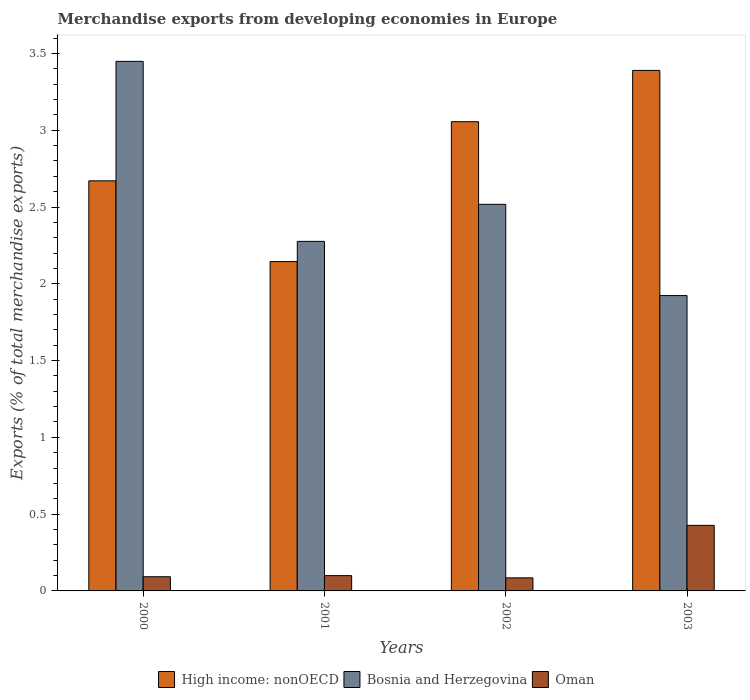How many groups of bars are there?
Provide a succinct answer. 4. How many bars are there on the 2nd tick from the left?
Provide a short and direct response. 3. How many bars are there on the 4th tick from the right?
Offer a terse response. 3. In how many cases, is the number of bars for a given year not equal to the number of legend labels?
Your response must be concise. 0. What is the percentage of total merchandise exports in Bosnia and Herzegovina in 2000?
Provide a succinct answer. 3.45. Across all years, what is the maximum percentage of total merchandise exports in High income: nonOECD?
Make the answer very short. 3.39. Across all years, what is the minimum percentage of total merchandise exports in High income: nonOECD?
Provide a short and direct response. 2.14. In which year was the percentage of total merchandise exports in High income: nonOECD minimum?
Give a very brief answer. 2001. What is the total percentage of total merchandise exports in Oman in the graph?
Keep it short and to the point. 0.7. What is the difference between the percentage of total merchandise exports in Bosnia and Herzegovina in 2002 and that in 2003?
Give a very brief answer. 0.59. What is the difference between the percentage of total merchandise exports in High income: nonOECD in 2000 and the percentage of total merchandise exports in Oman in 2001?
Make the answer very short. 2.57. What is the average percentage of total merchandise exports in Oman per year?
Ensure brevity in your answer.  0.18. In the year 2003, what is the difference between the percentage of total merchandise exports in Oman and percentage of total merchandise exports in Bosnia and Herzegovina?
Your answer should be compact. -1.5. In how many years, is the percentage of total merchandise exports in High income: nonOECD greater than 1.5 %?
Your response must be concise. 4. What is the ratio of the percentage of total merchandise exports in High income: nonOECD in 2001 to that in 2002?
Keep it short and to the point. 0.7. What is the difference between the highest and the second highest percentage of total merchandise exports in Oman?
Offer a very short reply. 0.33. What is the difference between the highest and the lowest percentage of total merchandise exports in High income: nonOECD?
Make the answer very short. 1.24. In how many years, is the percentage of total merchandise exports in High income: nonOECD greater than the average percentage of total merchandise exports in High income: nonOECD taken over all years?
Your answer should be compact. 2. Is the sum of the percentage of total merchandise exports in High income: nonOECD in 2000 and 2002 greater than the maximum percentage of total merchandise exports in Bosnia and Herzegovina across all years?
Offer a very short reply. Yes. What does the 1st bar from the left in 2001 represents?
Your response must be concise. High income: nonOECD. What does the 3rd bar from the right in 2002 represents?
Give a very brief answer. High income: nonOECD. Are all the bars in the graph horizontal?
Offer a very short reply. No. How many years are there in the graph?
Provide a short and direct response. 4. What is the difference between two consecutive major ticks on the Y-axis?
Offer a very short reply. 0.5. Are the values on the major ticks of Y-axis written in scientific E-notation?
Your answer should be very brief. No. How many legend labels are there?
Provide a succinct answer. 3. How are the legend labels stacked?
Your response must be concise. Horizontal. What is the title of the graph?
Provide a succinct answer. Merchandise exports from developing economies in Europe. Does "St. Lucia" appear as one of the legend labels in the graph?
Provide a succinct answer. No. What is the label or title of the X-axis?
Your answer should be very brief. Years. What is the label or title of the Y-axis?
Provide a short and direct response. Exports (% of total merchandise exports). What is the Exports (% of total merchandise exports) in High income: nonOECD in 2000?
Ensure brevity in your answer.  2.67. What is the Exports (% of total merchandise exports) in Bosnia and Herzegovina in 2000?
Ensure brevity in your answer.  3.45. What is the Exports (% of total merchandise exports) in Oman in 2000?
Give a very brief answer. 0.09. What is the Exports (% of total merchandise exports) in High income: nonOECD in 2001?
Your response must be concise. 2.14. What is the Exports (% of total merchandise exports) in Bosnia and Herzegovina in 2001?
Ensure brevity in your answer.  2.28. What is the Exports (% of total merchandise exports) in Oman in 2001?
Offer a terse response. 0.1. What is the Exports (% of total merchandise exports) of High income: nonOECD in 2002?
Your answer should be very brief. 3.06. What is the Exports (% of total merchandise exports) in Bosnia and Herzegovina in 2002?
Your response must be concise. 2.52. What is the Exports (% of total merchandise exports) in Oman in 2002?
Your answer should be compact. 0.09. What is the Exports (% of total merchandise exports) of High income: nonOECD in 2003?
Your response must be concise. 3.39. What is the Exports (% of total merchandise exports) of Bosnia and Herzegovina in 2003?
Your response must be concise. 1.92. What is the Exports (% of total merchandise exports) of Oman in 2003?
Provide a short and direct response. 0.43. Across all years, what is the maximum Exports (% of total merchandise exports) in High income: nonOECD?
Keep it short and to the point. 3.39. Across all years, what is the maximum Exports (% of total merchandise exports) in Bosnia and Herzegovina?
Your response must be concise. 3.45. Across all years, what is the maximum Exports (% of total merchandise exports) in Oman?
Ensure brevity in your answer.  0.43. Across all years, what is the minimum Exports (% of total merchandise exports) in High income: nonOECD?
Your response must be concise. 2.14. Across all years, what is the minimum Exports (% of total merchandise exports) of Bosnia and Herzegovina?
Provide a short and direct response. 1.92. Across all years, what is the minimum Exports (% of total merchandise exports) of Oman?
Provide a short and direct response. 0.09. What is the total Exports (% of total merchandise exports) of High income: nonOECD in the graph?
Your response must be concise. 11.26. What is the total Exports (% of total merchandise exports) of Bosnia and Herzegovina in the graph?
Your answer should be very brief. 10.17. What is the total Exports (% of total merchandise exports) of Oman in the graph?
Keep it short and to the point. 0.7. What is the difference between the Exports (% of total merchandise exports) in High income: nonOECD in 2000 and that in 2001?
Your answer should be very brief. 0.53. What is the difference between the Exports (% of total merchandise exports) in Bosnia and Herzegovina in 2000 and that in 2001?
Your answer should be very brief. 1.17. What is the difference between the Exports (% of total merchandise exports) of Oman in 2000 and that in 2001?
Offer a terse response. -0.01. What is the difference between the Exports (% of total merchandise exports) in High income: nonOECD in 2000 and that in 2002?
Give a very brief answer. -0.39. What is the difference between the Exports (% of total merchandise exports) of Bosnia and Herzegovina in 2000 and that in 2002?
Your answer should be very brief. 0.93. What is the difference between the Exports (% of total merchandise exports) of Oman in 2000 and that in 2002?
Offer a terse response. 0.01. What is the difference between the Exports (% of total merchandise exports) of High income: nonOECD in 2000 and that in 2003?
Provide a short and direct response. -0.72. What is the difference between the Exports (% of total merchandise exports) in Bosnia and Herzegovina in 2000 and that in 2003?
Keep it short and to the point. 1.53. What is the difference between the Exports (% of total merchandise exports) of Oman in 2000 and that in 2003?
Your answer should be very brief. -0.33. What is the difference between the Exports (% of total merchandise exports) of High income: nonOECD in 2001 and that in 2002?
Your response must be concise. -0.91. What is the difference between the Exports (% of total merchandise exports) in Bosnia and Herzegovina in 2001 and that in 2002?
Keep it short and to the point. -0.24. What is the difference between the Exports (% of total merchandise exports) in Oman in 2001 and that in 2002?
Your response must be concise. 0.01. What is the difference between the Exports (% of total merchandise exports) in High income: nonOECD in 2001 and that in 2003?
Provide a short and direct response. -1.24. What is the difference between the Exports (% of total merchandise exports) of Bosnia and Herzegovina in 2001 and that in 2003?
Ensure brevity in your answer.  0.35. What is the difference between the Exports (% of total merchandise exports) of Oman in 2001 and that in 2003?
Offer a terse response. -0.33. What is the difference between the Exports (% of total merchandise exports) of High income: nonOECD in 2002 and that in 2003?
Offer a terse response. -0.33. What is the difference between the Exports (% of total merchandise exports) in Bosnia and Herzegovina in 2002 and that in 2003?
Offer a very short reply. 0.59. What is the difference between the Exports (% of total merchandise exports) of Oman in 2002 and that in 2003?
Your answer should be compact. -0.34. What is the difference between the Exports (% of total merchandise exports) of High income: nonOECD in 2000 and the Exports (% of total merchandise exports) of Bosnia and Herzegovina in 2001?
Your answer should be very brief. 0.39. What is the difference between the Exports (% of total merchandise exports) of High income: nonOECD in 2000 and the Exports (% of total merchandise exports) of Oman in 2001?
Offer a terse response. 2.57. What is the difference between the Exports (% of total merchandise exports) in Bosnia and Herzegovina in 2000 and the Exports (% of total merchandise exports) in Oman in 2001?
Make the answer very short. 3.35. What is the difference between the Exports (% of total merchandise exports) in High income: nonOECD in 2000 and the Exports (% of total merchandise exports) in Bosnia and Herzegovina in 2002?
Provide a succinct answer. 0.15. What is the difference between the Exports (% of total merchandise exports) in High income: nonOECD in 2000 and the Exports (% of total merchandise exports) in Oman in 2002?
Provide a short and direct response. 2.59. What is the difference between the Exports (% of total merchandise exports) in Bosnia and Herzegovina in 2000 and the Exports (% of total merchandise exports) in Oman in 2002?
Your answer should be compact. 3.36. What is the difference between the Exports (% of total merchandise exports) of High income: nonOECD in 2000 and the Exports (% of total merchandise exports) of Bosnia and Herzegovina in 2003?
Keep it short and to the point. 0.75. What is the difference between the Exports (% of total merchandise exports) of High income: nonOECD in 2000 and the Exports (% of total merchandise exports) of Oman in 2003?
Offer a very short reply. 2.24. What is the difference between the Exports (% of total merchandise exports) in Bosnia and Herzegovina in 2000 and the Exports (% of total merchandise exports) in Oman in 2003?
Keep it short and to the point. 3.02. What is the difference between the Exports (% of total merchandise exports) of High income: nonOECD in 2001 and the Exports (% of total merchandise exports) of Bosnia and Herzegovina in 2002?
Your answer should be compact. -0.37. What is the difference between the Exports (% of total merchandise exports) of High income: nonOECD in 2001 and the Exports (% of total merchandise exports) of Oman in 2002?
Give a very brief answer. 2.06. What is the difference between the Exports (% of total merchandise exports) of Bosnia and Herzegovina in 2001 and the Exports (% of total merchandise exports) of Oman in 2002?
Ensure brevity in your answer.  2.19. What is the difference between the Exports (% of total merchandise exports) in High income: nonOECD in 2001 and the Exports (% of total merchandise exports) in Bosnia and Herzegovina in 2003?
Ensure brevity in your answer.  0.22. What is the difference between the Exports (% of total merchandise exports) of High income: nonOECD in 2001 and the Exports (% of total merchandise exports) of Oman in 2003?
Offer a very short reply. 1.72. What is the difference between the Exports (% of total merchandise exports) in Bosnia and Herzegovina in 2001 and the Exports (% of total merchandise exports) in Oman in 2003?
Ensure brevity in your answer.  1.85. What is the difference between the Exports (% of total merchandise exports) in High income: nonOECD in 2002 and the Exports (% of total merchandise exports) in Bosnia and Herzegovina in 2003?
Keep it short and to the point. 1.13. What is the difference between the Exports (% of total merchandise exports) of High income: nonOECD in 2002 and the Exports (% of total merchandise exports) of Oman in 2003?
Keep it short and to the point. 2.63. What is the difference between the Exports (% of total merchandise exports) in Bosnia and Herzegovina in 2002 and the Exports (% of total merchandise exports) in Oman in 2003?
Ensure brevity in your answer.  2.09. What is the average Exports (% of total merchandise exports) in High income: nonOECD per year?
Provide a short and direct response. 2.81. What is the average Exports (% of total merchandise exports) in Bosnia and Herzegovina per year?
Provide a succinct answer. 2.54. What is the average Exports (% of total merchandise exports) in Oman per year?
Your response must be concise. 0.18. In the year 2000, what is the difference between the Exports (% of total merchandise exports) of High income: nonOECD and Exports (% of total merchandise exports) of Bosnia and Herzegovina?
Provide a short and direct response. -0.78. In the year 2000, what is the difference between the Exports (% of total merchandise exports) in High income: nonOECD and Exports (% of total merchandise exports) in Oman?
Keep it short and to the point. 2.58. In the year 2000, what is the difference between the Exports (% of total merchandise exports) in Bosnia and Herzegovina and Exports (% of total merchandise exports) in Oman?
Make the answer very short. 3.36. In the year 2001, what is the difference between the Exports (% of total merchandise exports) of High income: nonOECD and Exports (% of total merchandise exports) of Bosnia and Herzegovina?
Offer a very short reply. -0.13. In the year 2001, what is the difference between the Exports (% of total merchandise exports) of High income: nonOECD and Exports (% of total merchandise exports) of Oman?
Provide a short and direct response. 2.05. In the year 2001, what is the difference between the Exports (% of total merchandise exports) of Bosnia and Herzegovina and Exports (% of total merchandise exports) of Oman?
Give a very brief answer. 2.18. In the year 2002, what is the difference between the Exports (% of total merchandise exports) of High income: nonOECD and Exports (% of total merchandise exports) of Bosnia and Herzegovina?
Make the answer very short. 0.54. In the year 2002, what is the difference between the Exports (% of total merchandise exports) of High income: nonOECD and Exports (% of total merchandise exports) of Oman?
Offer a terse response. 2.97. In the year 2002, what is the difference between the Exports (% of total merchandise exports) in Bosnia and Herzegovina and Exports (% of total merchandise exports) in Oman?
Make the answer very short. 2.43. In the year 2003, what is the difference between the Exports (% of total merchandise exports) of High income: nonOECD and Exports (% of total merchandise exports) of Bosnia and Herzegovina?
Your answer should be compact. 1.47. In the year 2003, what is the difference between the Exports (% of total merchandise exports) in High income: nonOECD and Exports (% of total merchandise exports) in Oman?
Provide a succinct answer. 2.96. In the year 2003, what is the difference between the Exports (% of total merchandise exports) of Bosnia and Herzegovina and Exports (% of total merchandise exports) of Oman?
Keep it short and to the point. 1.5. What is the ratio of the Exports (% of total merchandise exports) in High income: nonOECD in 2000 to that in 2001?
Make the answer very short. 1.25. What is the ratio of the Exports (% of total merchandise exports) in Bosnia and Herzegovina in 2000 to that in 2001?
Provide a succinct answer. 1.51. What is the ratio of the Exports (% of total merchandise exports) of Oman in 2000 to that in 2001?
Keep it short and to the point. 0.93. What is the ratio of the Exports (% of total merchandise exports) in High income: nonOECD in 2000 to that in 2002?
Offer a terse response. 0.87. What is the ratio of the Exports (% of total merchandise exports) of Bosnia and Herzegovina in 2000 to that in 2002?
Offer a terse response. 1.37. What is the ratio of the Exports (% of total merchandise exports) in Oman in 2000 to that in 2002?
Your response must be concise. 1.09. What is the ratio of the Exports (% of total merchandise exports) of High income: nonOECD in 2000 to that in 2003?
Your answer should be very brief. 0.79. What is the ratio of the Exports (% of total merchandise exports) of Bosnia and Herzegovina in 2000 to that in 2003?
Your response must be concise. 1.79. What is the ratio of the Exports (% of total merchandise exports) of Oman in 2000 to that in 2003?
Offer a very short reply. 0.22. What is the ratio of the Exports (% of total merchandise exports) of High income: nonOECD in 2001 to that in 2002?
Give a very brief answer. 0.7. What is the ratio of the Exports (% of total merchandise exports) in Bosnia and Herzegovina in 2001 to that in 2002?
Provide a short and direct response. 0.9. What is the ratio of the Exports (% of total merchandise exports) in Oman in 2001 to that in 2002?
Your answer should be very brief. 1.17. What is the ratio of the Exports (% of total merchandise exports) in High income: nonOECD in 2001 to that in 2003?
Your response must be concise. 0.63. What is the ratio of the Exports (% of total merchandise exports) of Bosnia and Herzegovina in 2001 to that in 2003?
Provide a succinct answer. 1.18. What is the ratio of the Exports (% of total merchandise exports) in Oman in 2001 to that in 2003?
Provide a short and direct response. 0.23. What is the ratio of the Exports (% of total merchandise exports) in High income: nonOECD in 2002 to that in 2003?
Give a very brief answer. 0.9. What is the ratio of the Exports (% of total merchandise exports) of Bosnia and Herzegovina in 2002 to that in 2003?
Provide a short and direct response. 1.31. What is the ratio of the Exports (% of total merchandise exports) of Oman in 2002 to that in 2003?
Your answer should be compact. 0.2. What is the difference between the highest and the second highest Exports (% of total merchandise exports) of High income: nonOECD?
Give a very brief answer. 0.33. What is the difference between the highest and the second highest Exports (% of total merchandise exports) of Bosnia and Herzegovina?
Keep it short and to the point. 0.93. What is the difference between the highest and the second highest Exports (% of total merchandise exports) of Oman?
Give a very brief answer. 0.33. What is the difference between the highest and the lowest Exports (% of total merchandise exports) of High income: nonOECD?
Ensure brevity in your answer.  1.24. What is the difference between the highest and the lowest Exports (% of total merchandise exports) of Bosnia and Herzegovina?
Give a very brief answer. 1.53. What is the difference between the highest and the lowest Exports (% of total merchandise exports) in Oman?
Ensure brevity in your answer.  0.34. 